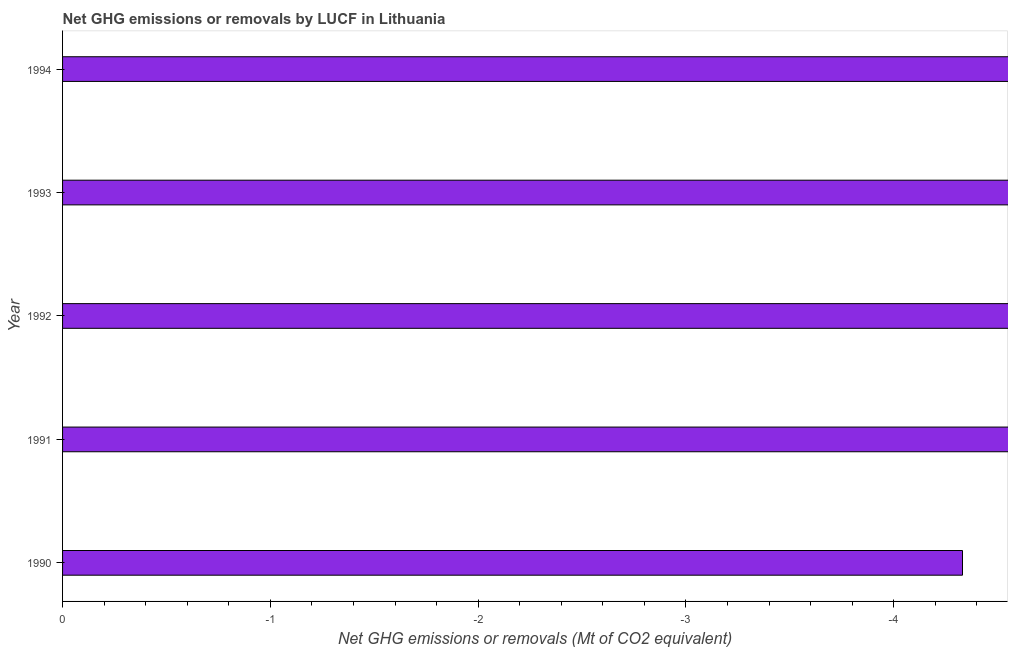Does the graph contain any zero values?
Your answer should be compact. Yes. Does the graph contain grids?
Your response must be concise. No. What is the title of the graph?
Your answer should be very brief. Net GHG emissions or removals by LUCF in Lithuania. What is the label or title of the X-axis?
Keep it short and to the point. Net GHG emissions or removals (Mt of CO2 equivalent). What is the label or title of the Y-axis?
Offer a very short reply. Year. What is the sum of the ghg net emissions or removals?
Your response must be concise. 0. What is the average ghg net emissions or removals per year?
Your answer should be compact. 0. In how many years, is the ghg net emissions or removals greater than -4.4 Mt?
Provide a short and direct response. 1. In how many years, is the ghg net emissions or removals greater than the average ghg net emissions or removals taken over all years?
Ensure brevity in your answer.  0. How many bars are there?
Keep it short and to the point. 0. What is the difference between two consecutive major ticks on the X-axis?
Your answer should be compact. 1. 